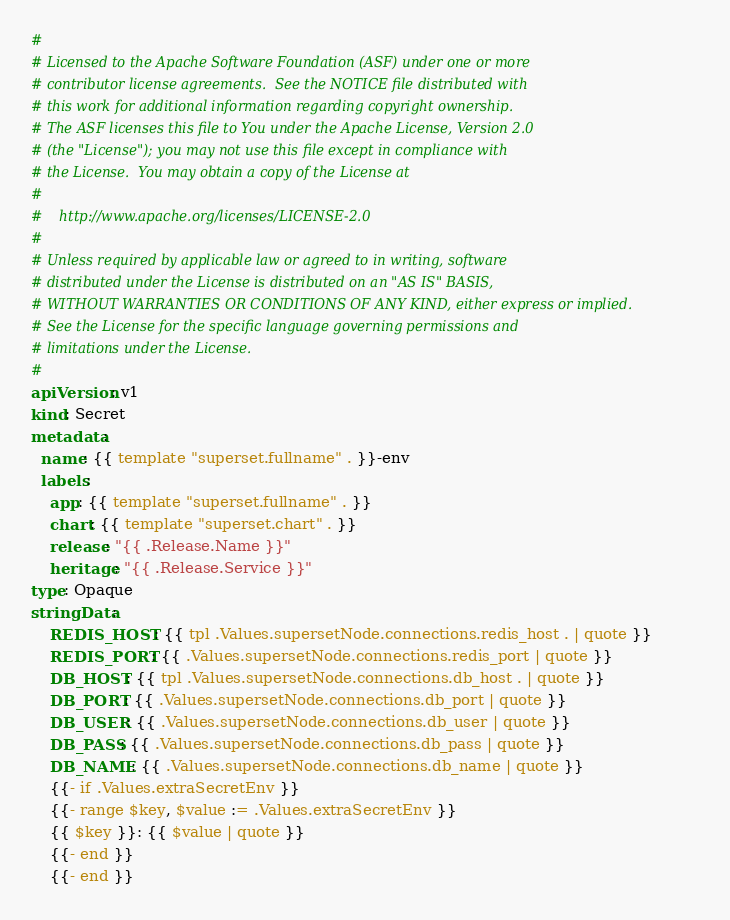<code> <loc_0><loc_0><loc_500><loc_500><_YAML_>#
# Licensed to the Apache Software Foundation (ASF) under one or more
# contributor license agreements.  See the NOTICE file distributed with
# this work for additional information regarding copyright ownership.
# The ASF licenses this file to You under the Apache License, Version 2.0
# (the "License"); you may not use this file except in compliance with
# the License.  You may obtain a copy of the License at
#
#    http://www.apache.org/licenses/LICENSE-2.0
#
# Unless required by applicable law or agreed to in writing, software
# distributed under the License is distributed on an "AS IS" BASIS,
# WITHOUT WARRANTIES OR CONDITIONS OF ANY KIND, either express or implied.
# See the License for the specific language governing permissions and
# limitations under the License.
#
apiVersion: v1
kind: Secret
metadata:
  name: {{ template "superset.fullname" . }}-env
  labels:
    app: {{ template "superset.fullname" . }}
    chart: {{ template "superset.chart" . }}
    release: "{{ .Release.Name }}"
    heritage: "{{ .Release.Service }}"
type: Opaque
stringData:
    REDIS_HOST: {{ tpl .Values.supersetNode.connections.redis_host . | quote }}
    REDIS_PORT: {{ .Values.supersetNode.connections.redis_port | quote }}
    DB_HOST: {{ tpl .Values.supersetNode.connections.db_host . | quote }}
    DB_PORT: {{ .Values.supersetNode.connections.db_port | quote }}
    DB_USER: {{ .Values.supersetNode.connections.db_user | quote }}
    DB_PASS: {{ .Values.supersetNode.connections.db_pass | quote }}
    DB_NAME: {{ .Values.supersetNode.connections.db_name | quote }}
    {{- if .Values.extraSecretEnv }}
    {{- range $key, $value := .Values.extraSecretEnv }}
    {{ $key }}: {{ $value | quote }}
    {{- end }}
    {{- end }}
</code> 